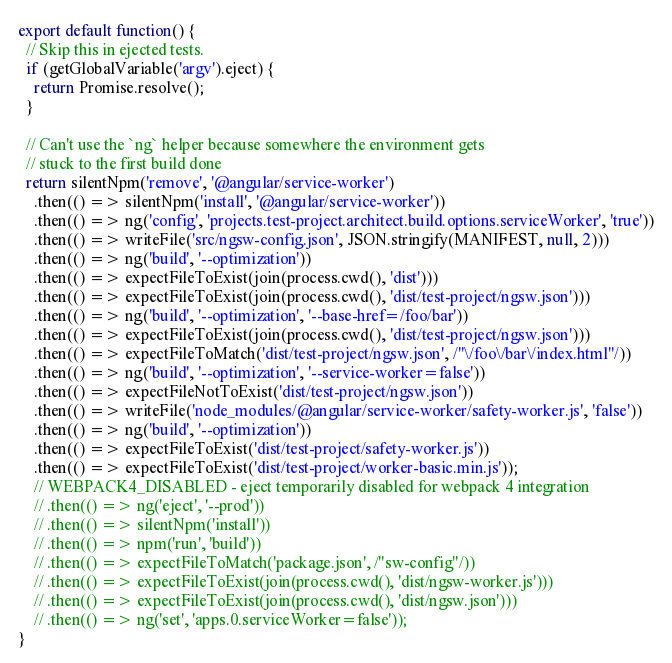Convert code to text. <code><loc_0><loc_0><loc_500><loc_500><_TypeScript_>export default function() {
  // Skip this in ejected tests.
  if (getGlobalVariable('argv').eject) {
    return Promise.resolve();
  }

  // Can't use the `ng` helper because somewhere the environment gets
  // stuck to the first build done
  return silentNpm('remove', '@angular/service-worker')
    .then(() => silentNpm('install', '@angular/service-worker'))
    .then(() => ng('config', 'projects.test-project.architect.build.options.serviceWorker', 'true'))
    .then(() => writeFile('src/ngsw-config.json', JSON.stringify(MANIFEST, null, 2)))
    .then(() => ng('build', '--optimization'))
    .then(() => expectFileToExist(join(process.cwd(), 'dist')))
    .then(() => expectFileToExist(join(process.cwd(), 'dist/test-project/ngsw.json')))
    .then(() => ng('build', '--optimization', '--base-href=/foo/bar'))
    .then(() => expectFileToExist(join(process.cwd(), 'dist/test-project/ngsw.json')))
    .then(() => expectFileToMatch('dist/test-project/ngsw.json', /"\/foo\/bar\/index.html"/))
    .then(() => ng('build', '--optimization', '--service-worker=false'))
    .then(() => expectFileNotToExist('dist/test-project/ngsw.json'))
    .then(() => writeFile('node_modules/@angular/service-worker/safety-worker.js', 'false'))
    .then(() => ng('build', '--optimization'))
    .then(() => expectFileToExist('dist/test-project/safety-worker.js'))
    .then(() => expectFileToExist('dist/test-project/worker-basic.min.js'));
    // WEBPACK4_DISABLED - eject temporarily disabled for webpack 4 integration
    // .then(() => ng('eject', '--prod'))
    // .then(() => silentNpm('install'))
    // .then(() => npm('run', 'build'))
    // .then(() => expectFileToMatch('package.json', /"sw-config"/))
    // .then(() => expectFileToExist(join(process.cwd(), 'dist/ngsw-worker.js')))
    // .then(() => expectFileToExist(join(process.cwd(), 'dist/ngsw.json')))
    // .then(() => ng('set', 'apps.0.serviceWorker=false'));
}
</code> 